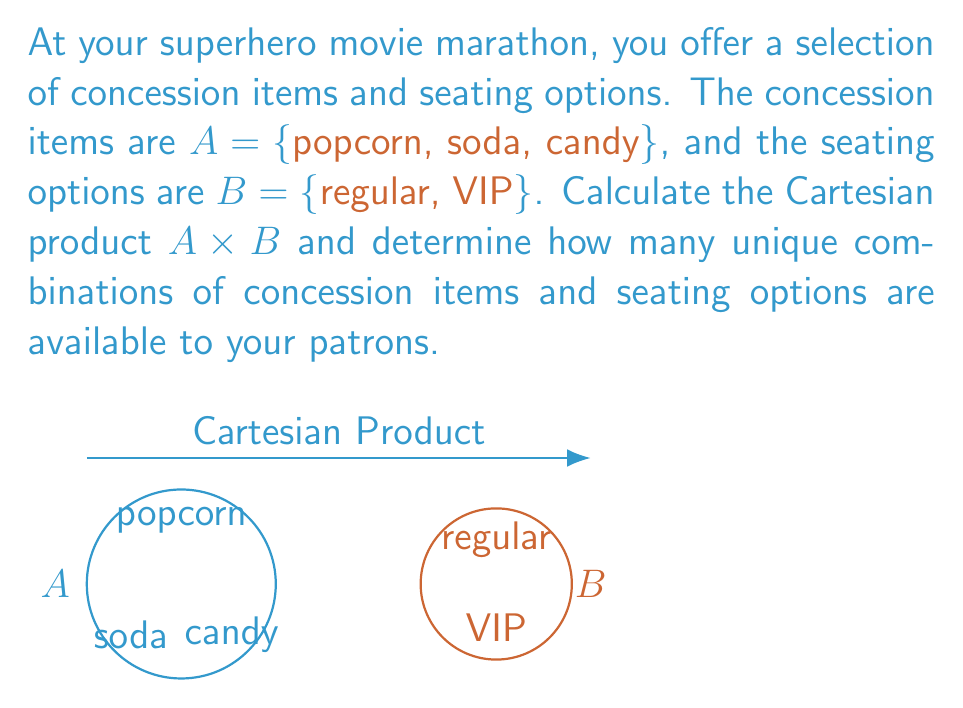Can you answer this question? To solve this problem, we need to understand the concept of Cartesian product and apply it to the given sets.

1. The Cartesian product of two sets $A$ and $B$, denoted as $A \times B$, is the set of all ordered pairs $(a, b)$ where $a \in A$ and $b \in B$.

2. In this case:
   $A = \{popcorn, soda, candy\}$
   $B = \{regular, VIP\}$

3. To compute $A \times B$, we pair each element from set $A$ with each element from set $B$:

   $A \times B = \{(popcorn, regular), (popcorn, VIP),$
                $(soda, regular), (soda, VIP),$
                $(candy, regular), (candy, VIP)\}$

4. To determine the number of unique combinations, we can use the multiplication principle:
   $|A \times B| = |A| \cdot |B|$

   Where $|A|$ is the number of elements in set $A$, and $|B|$ is the number of elements in set $B$.

5. In this case:
   $|A| = 3$ (popcorn, soda, candy)
   $|B| = 2$ (regular, VIP)

6. Therefore, the number of unique combinations is:
   $|A \times B| = 3 \cdot 2 = 6$

This matches the number of ordered pairs we listed in step 3.
Answer: $A \times B = \{(popcorn, regular), (popcorn, VIP), (soda, regular), (soda, VIP), (candy, regular), (candy, VIP)\}$; 6 combinations 